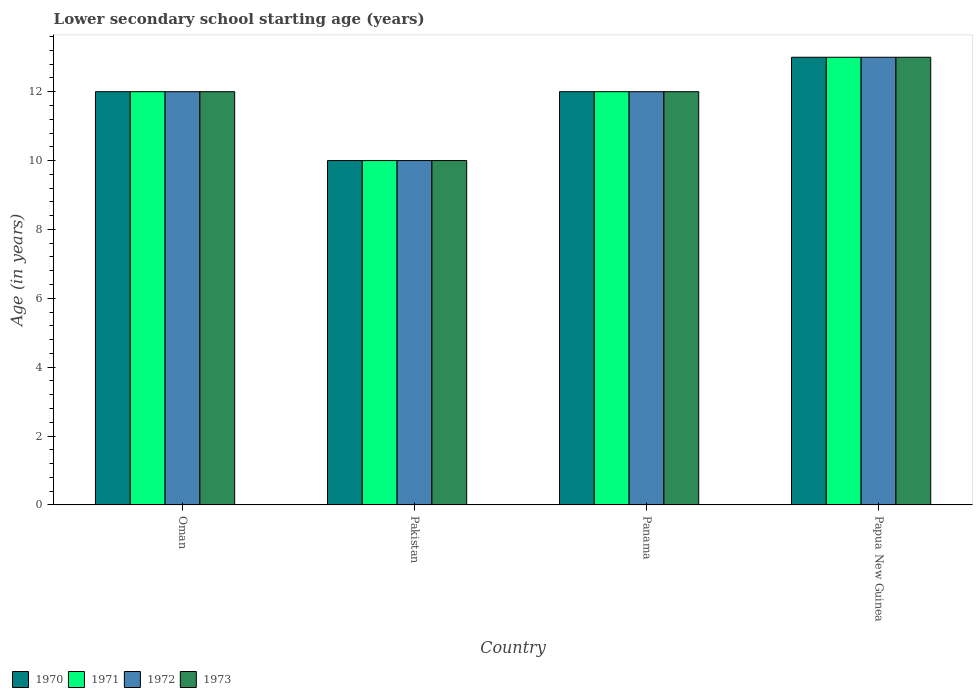How many groups of bars are there?
Make the answer very short. 4. How many bars are there on the 4th tick from the right?
Your answer should be compact. 4. What is the label of the 1st group of bars from the left?
Ensure brevity in your answer.  Oman. What is the lower secondary school starting age of children in 1973 in Panama?
Provide a short and direct response. 12. Across all countries, what is the maximum lower secondary school starting age of children in 1973?
Offer a terse response. 13. Across all countries, what is the minimum lower secondary school starting age of children in 1973?
Your answer should be very brief. 10. In which country was the lower secondary school starting age of children in 1971 maximum?
Your answer should be compact. Papua New Guinea. What is the total lower secondary school starting age of children in 1971 in the graph?
Your response must be concise. 47. What is the average lower secondary school starting age of children in 1973 per country?
Your answer should be compact. 11.75. What is the difference between the lower secondary school starting age of children of/in 1972 and lower secondary school starting age of children of/in 1973 in Oman?
Provide a succinct answer. 0. What is the ratio of the lower secondary school starting age of children in 1972 in Pakistan to that in Panama?
Provide a succinct answer. 0.83. Is the difference between the lower secondary school starting age of children in 1972 in Pakistan and Papua New Guinea greater than the difference between the lower secondary school starting age of children in 1973 in Pakistan and Papua New Guinea?
Make the answer very short. No. What is the difference between the highest and the second highest lower secondary school starting age of children in 1971?
Offer a very short reply. -1. What is the difference between the highest and the lowest lower secondary school starting age of children in 1972?
Your answer should be very brief. 3. Is it the case that in every country, the sum of the lower secondary school starting age of children in 1970 and lower secondary school starting age of children in 1971 is greater than the sum of lower secondary school starting age of children in 1972 and lower secondary school starting age of children in 1973?
Provide a short and direct response. No. What does the 1st bar from the left in Oman represents?
Provide a short and direct response. 1970. How many bars are there?
Provide a succinct answer. 16. How many countries are there in the graph?
Make the answer very short. 4. Does the graph contain any zero values?
Your answer should be very brief. No. Where does the legend appear in the graph?
Your answer should be very brief. Bottom left. How many legend labels are there?
Make the answer very short. 4. What is the title of the graph?
Your answer should be compact. Lower secondary school starting age (years). What is the label or title of the X-axis?
Your response must be concise. Country. What is the label or title of the Y-axis?
Ensure brevity in your answer.  Age (in years). What is the Age (in years) in 1970 in Oman?
Make the answer very short. 12. What is the Age (in years) of 1971 in Oman?
Offer a very short reply. 12. What is the Age (in years) in 1973 in Oman?
Keep it short and to the point. 12. What is the Age (in years) of 1970 in Pakistan?
Your response must be concise. 10. What is the Age (in years) in 1973 in Pakistan?
Your answer should be very brief. 10. What is the Age (in years) of 1971 in Panama?
Offer a very short reply. 12. What is the Age (in years) in 1973 in Panama?
Your answer should be compact. 12. What is the Age (in years) of 1970 in Papua New Guinea?
Make the answer very short. 13. What is the Age (in years) in 1971 in Papua New Guinea?
Your answer should be very brief. 13. What is the Age (in years) of 1972 in Papua New Guinea?
Offer a terse response. 13. Across all countries, what is the maximum Age (in years) of 1972?
Your response must be concise. 13. Across all countries, what is the maximum Age (in years) of 1973?
Offer a very short reply. 13. Across all countries, what is the minimum Age (in years) of 1971?
Offer a terse response. 10. Across all countries, what is the minimum Age (in years) in 1972?
Offer a terse response. 10. Across all countries, what is the minimum Age (in years) of 1973?
Give a very brief answer. 10. What is the total Age (in years) of 1970 in the graph?
Keep it short and to the point. 47. What is the difference between the Age (in years) of 1970 in Oman and that in Pakistan?
Your answer should be very brief. 2. What is the difference between the Age (in years) of 1971 in Oman and that in Pakistan?
Offer a very short reply. 2. What is the difference between the Age (in years) in 1972 in Oman and that in Pakistan?
Offer a terse response. 2. What is the difference between the Age (in years) of 1970 in Oman and that in Panama?
Keep it short and to the point. 0. What is the difference between the Age (in years) in 1973 in Oman and that in Panama?
Provide a succinct answer. 0. What is the difference between the Age (in years) of 1971 in Oman and that in Papua New Guinea?
Offer a terse response. -1. What is the difference between the Age (in years) of 1972 in Oman and that in Papua New Guinea?
Your answer should be compact. -1. What is the difference between the Age (in years) of 1971 in Pakistan and that in Panama?
Keep it short and to the point. -2. What is the difference between the Age (in years) of 1970 in Pakistan and that in Papua New Guinea?
Provide a short and direct response. -3. What is the difference between the Age (in years) in 1971 in Pakistan and that in Papua New Guinea?
Provide a succinct answer. -3. What is the difference between the Age (in years) in 1972 in Pakistan and that in Papua New Guinea?
Offer a terse response. -3. What is the difference between the Age (in years) in 1973 in Pakistan and that in Papua New Guinea?
Provide a succinct answer. -3. What is the difference between the Age (in years) of 1970 in Panama and that in Papua New Guinea?
Keep it short and to the point. -1. What is the difference between the Age (in years) in 1970 in Oman and the Age (in years) in 1971 in Pakistan?
Your answer should be compact. 2. What is the difference between the Age (in years) of 1970 in Oman and the Age (in years) of 1973 in Pakistan?
Offer a very short reply. 2. What is the difference between the Age (in years) of 1971 in Oman and the Age (in years) of 1972 in Pakistan?
Offer a very short reply. 2. What is the difference between the Age (in years) in 1970 in Oman and the Age (in years) in 1971 in Panama?
Make the answer very short. 0. What is the difference between the Age (in years) of 1970 in Oman and the Age (in years) of 1972 in Panama?
Your answer should be compact. 0. What is the difference between the Age (in years) of 1971 in Oman and the Age (in years) of 1972 in Panama?
Offer a terse response. 0. What is the difference between the Age (in years) of 1971 in Oman and the Age (in years) of 1973 in Panama?
Your answer should be very brief. 0. What is the difference between the Age (in years) of 1971 in Oman and the Age (in years) of 1972 in Papua New Guinea?
Your answer should be very brief. -1. What is the difference between the Age (in years) of 1971 in Oman and the Age (in years) of 1973 in Papua New Guinea?
Your answer should be compact. -1. What is the difference between the Age (in years) of 1970 in Pakistan and the Age (in years) of 1971 in Panama?
Ensure brevity in your answer.  -2. What is the difference between the Age (in years) in 1972 in Pakistan and the Age (in years) in 1973 in Panama?
Provide a succinct answer. -2. What is the difference between the Age (in years) of 1970 in Pakistan and the Age (in years) of 1971 in Papua New Guinea?
Keep it short and to the point. -3. What is the difference between the Age (in years) in 1972 in Pakistan and the Age (in years) in 1973 in Papua New Guinea?
Keep it short and to the point. -3. What is the difference between the Age (in years) in 1970 in Panama and the Age (in years) in 1971 in Papua New Guinea?
Your answer should be very brief. -1. What is the difference between the Age (in years) of 1970 in Panama and the Age (in years) of 1973 in Papua New Guinea?
Ensure brevity in your answer.  -1. What is the difference between the Age (in years) in 1971 in Panama and the Age (in years) in 1973 in Papua New Guinea?
Make the answer very short. -1. What is the average Age (in years) in 1970 per country?
Your answer should be compact. 11.75. What is the average Age (in years) in 1971 per country?
Offer a very short reply. 11.75. What is the average Age (in years) in 1972 per country?
Provide a short and direct response. 11.75. What is the average Age (in years) of 1973 per country?
Offer a very short reply. 11.75. What is the difference between the Age (in years) in 1970 and Age (in years) in 1972 in Oman?
Your answer should be very brief. 0. What is the difference between the Age (in years) of 1970 and Age (in years) of 1973 in Oman?
Ensure brevity in your answer.  0. What is the difference between the Age (in years) in 1971 and Age (in years) in 1973 in Oman?
Offer a very short reply. 0. What is the difference between the Age (in years) in 1972 and Age (in years) in 1973 in Oman?
Give a very brief answer. 0. What is the difference between the Age (in years) of 1970 and Age (in years) of 1972 in Pakistan?
Your answer should be compact. 0. What is the difference between the Age (in years) of 1971 and Age (in years) of 1972 in Pakistan?
Give a very brief answer. 0. What is the difference between the Age (in years) of 1971 and Age (in years) of 1973 in Pakistan?
Your response must be concise. 0. What is the difference between the Age (in years) in 1972 and Age (in years) in 1973 in Pakistan?
Your answer should be very brief. 0. What is the difference between the Age (in years) in 1971 and Age (in years) in 1973 in Panama?
Ensure brevity in your answer.  0. What is the difference between the Age (in years) in 1972 and Age (in years) in 1973 in Panama?
Provide a succinct answer. 0. What is the difference between the Age (in years) in 1970 and Age (in years) in 1971 in Papua New Guinea?
Keep it short and to the point. 0. What is the difference between the Age (in years) of 1970 and Age (in years) of 1973 in Papua New Guinea?
Offer a very short reply. 0. What is the difference between the Age (in years) of 1971 and Age (in years) of 1972 in Papua New Guinea?
Provide a succinct answer. 0. What is the ratio of the Age (in years) in 1970 in Oman to that in Panama?
Provide a short and direct response. 1. What is the ratio of the Age (in years) of 1971 in Oman to that in Panama?
Keep it short and to the point. 1. What is the ratio of the Age (in years) in 1973 in Oman to that in Panama?
Your answer should be very brief. 1. What is the ratio of the Age (in years) in 1970 in Oman to that in Papua New Guinea?
Provide a succinct answer. 0.92. What is the ratio of the Age (in years) in 1971 in Oman to that in Papua New Guinea?
Provide a succinct answer. 0.92. What is the ratio of the Age (in years) of 1973 in Oman to that in Papua New Guinea?
Give a very brief answer. 0.92. What is the ratio of the Age (in years) of 1970 in Pakistan to that in Panama?
Offer a very short reply. 0.83. What is the ratio of the Age (in years) in 1971 in Pakistan to that in Panama?
Offer a terse response. 0.83. What is the ratio of the Age (in years) in 1973 in Pakistan to that in Panama?
Your answer should be compact. 0.83. What is the ratio of the Age (in years) of 1970 in Pakistan to that in Papua New Guinea?
Your response must be concise. 0.77. What is the ratio of the Age (in years) of 1971 in Pakistan to that in Papua New Guinea?
Offer a very short reply. 0.77. What is the ratio of the Age (in years) in 1972 in Pakistan to that in Papua New Guinea?
Provide a succinct answer. 0.77. What is the ratio of the Age (in years) in 1973 in Pakistan to that in Papua New Guinea?
Provide a short and direct response. 0.77. What is the ratio of the Age (in years) in 1970 in Panama to that in Papua New Guinea?
Your response must be concise. 0.92. What is the ratio of the Age (in years) in 1971 in Panama to that in Papua New Guinea?
Offer a terse response. 0.92. What is the difference between the highest and the second highest Age (in years) in 1970?
Provide a succinct answer. 1. What is the difference between the highest and the second highest Age (in years) of 1972?
Provide a succinct answer. 1. What is the difference between the highest and the second highest Age (in years) in 1973?
Offer a very short reply. 1. 